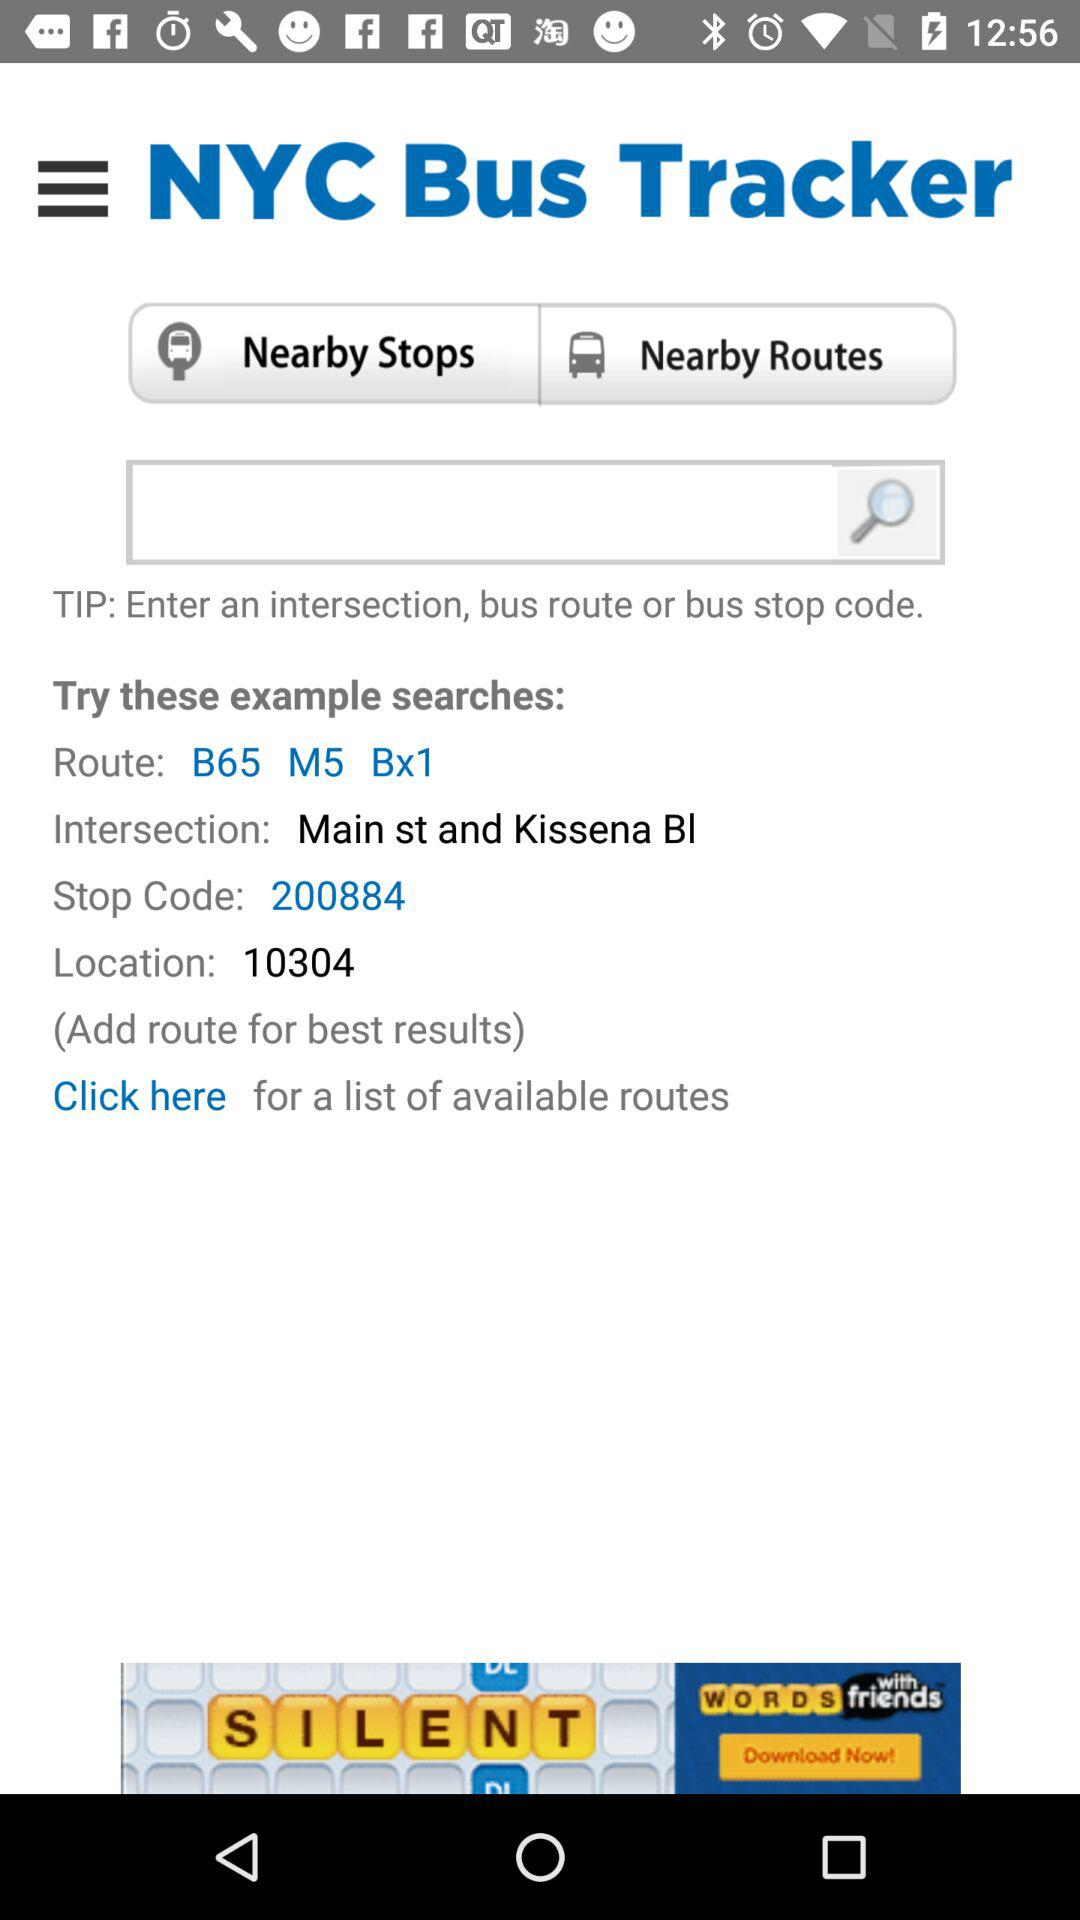What is the stop code? The stop code is "200884". 